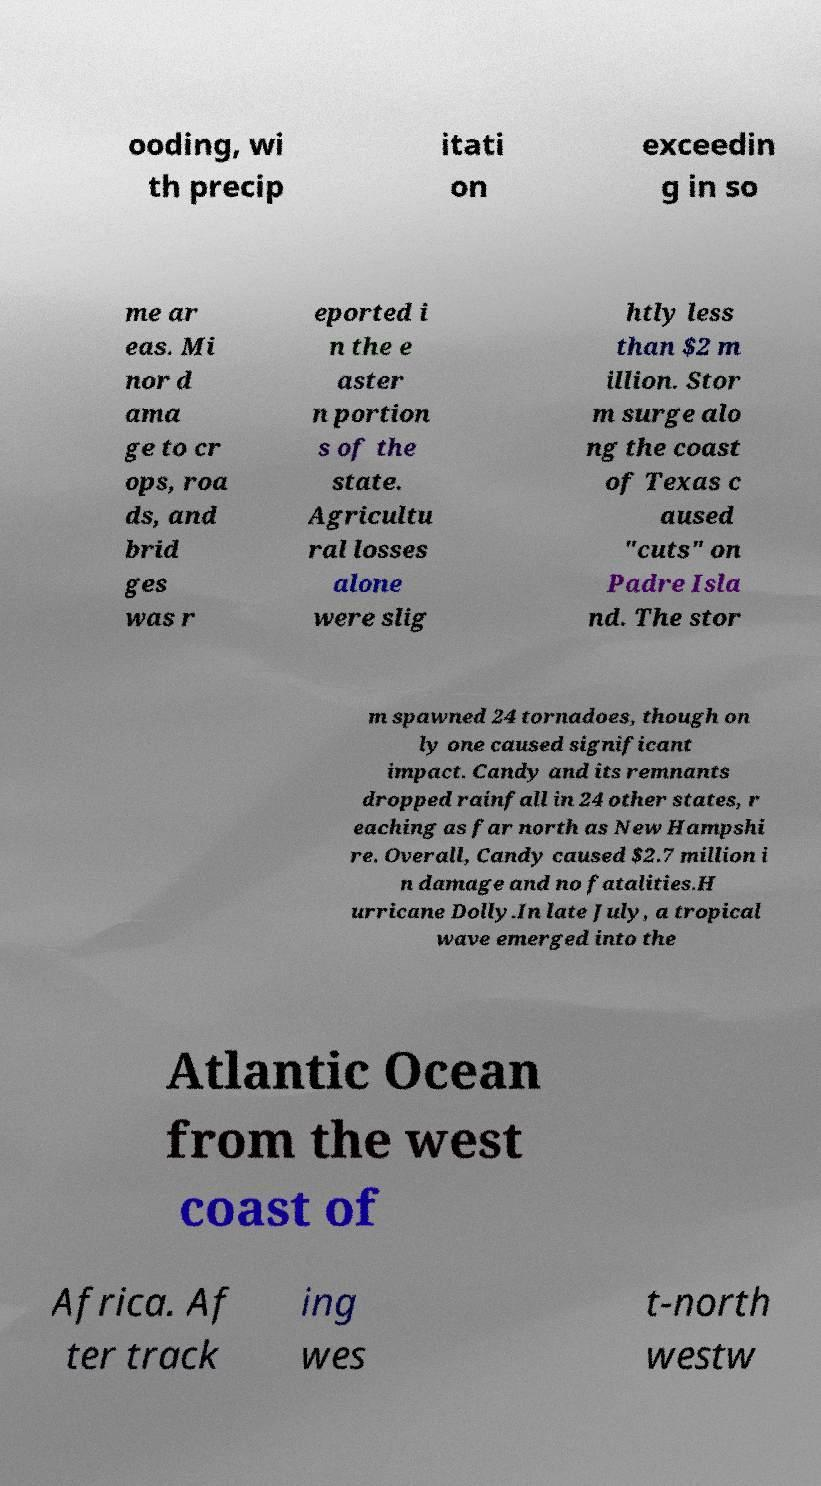I need the written content from this picture converted into text. Can you do that? ooding, wi th precip itati on exceedin g in so me ar eas. Mi nor d ama ge to cr ops, roa ds, and brid ges was r eported i n the e aster n portion s of the state. Agricultu ral losses alone were slig htly less than $2 m illion. Stor m surge alo ng the coast of Texas c aused "cuts" on Padre Isla nd. The stor m spawned 24 tornadoes, though on ly one caused significant impact. Candy and its remnants dropped rainfall in 24 other states, r eaching as far north as New Hampshi re. Overall, Candy caused $2.7 million i n damage and no fatalities.H urricane Dolly.In late July, a tropical wave emerged into the Atlantic Ocean from the west coast of Africa. Af ter track ing wes t-north westw 